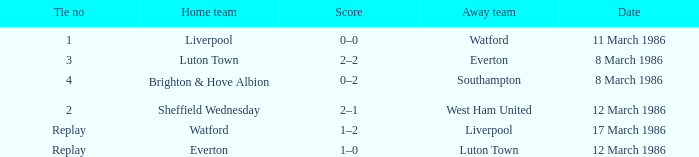What tie happened with Southampton? 4.0. 